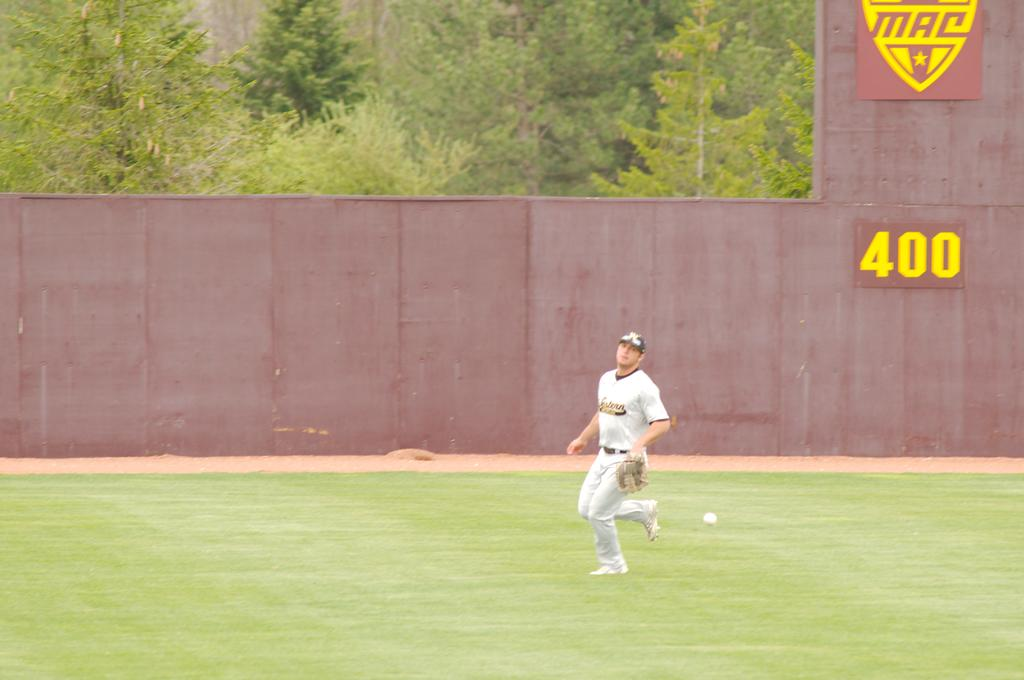Who is the main subject in the foreground of the image? There is a man in the foreground of the image. What is the man wearing? The man is wearing a white dress. Where is the man located in the image? The man is on the grass. What is happening with the ball in the image? The ball is in the air. What can be seen in the background of the image? There is a wall and trees in the background of the image. How many sisters does the man have, and are they present in the image? There is no information about the man's sisters in the image, so we cannot determine how many he has or if they are present. What type of chalk is being used to draw on the wall in the background? There is no chalk or drawing on the wall in the image. 